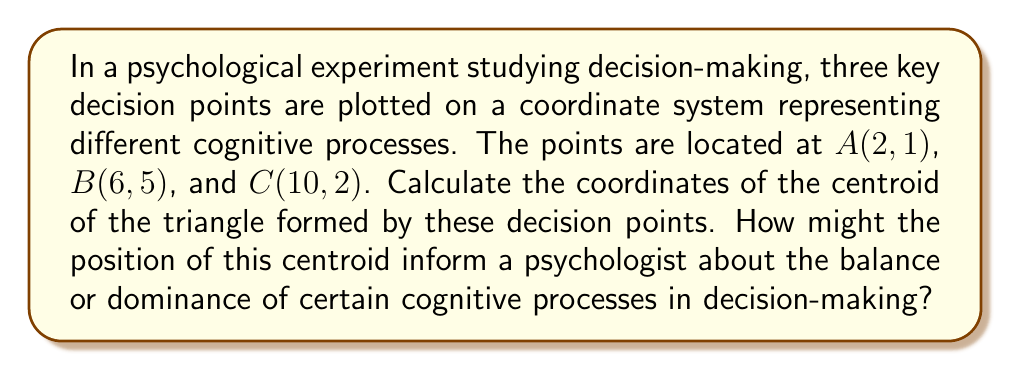Help me with this question. To solve this problem, we'll follow these steps:

1) The centroid of a triangle is located at the intersection of its medians. It can be calculated by averaging the x-coordinates and y-coordinates of the triangle's vertices.

2) The formula for the centroid (x, y) is:

   $$x = \frac{x_1 + x_2 + x_3}{3}$$
   $$y = \frac{y_1 + y_2 + y_3}{3}$$

   Where $(x_1, y_1)$, $(x_2, y_2)$, and $(x_3, y_3)$ are the coordinates of the triangle's vertices.

3) Let's substitute our values:
   A(2, 1), B(6, 5), C(10, 2)

   $$x = \frac{2 + 6 + 10}{3} = \frac{18}{3} = 6$$
   $$y = \frac{1 + 5 + 2}{3} = \frac{8}{3} \approx 2.67$$

4) Therefore, the centroid is located at (6, 2.67).

From a psychological perspective, the centroid's position could indicate the following:

- The x-coordinate (6) being at the midpoint of the x-axis range suggests a balance between the initial and final decision stages.
- The y-coordinate (2.67) being closer to the lower values might indicate a tendency towards more intuitive or automatic processing, as opposed to higher y-values which could represent more deliberate, analytical thinking.

This centroid could help psychologists understand the overall tendency in decision-making processes, potentially revealing biases or dominant cognitive strategies across the participant group.
Answer: The centroid of the triangle is located at (6, 2.67). 